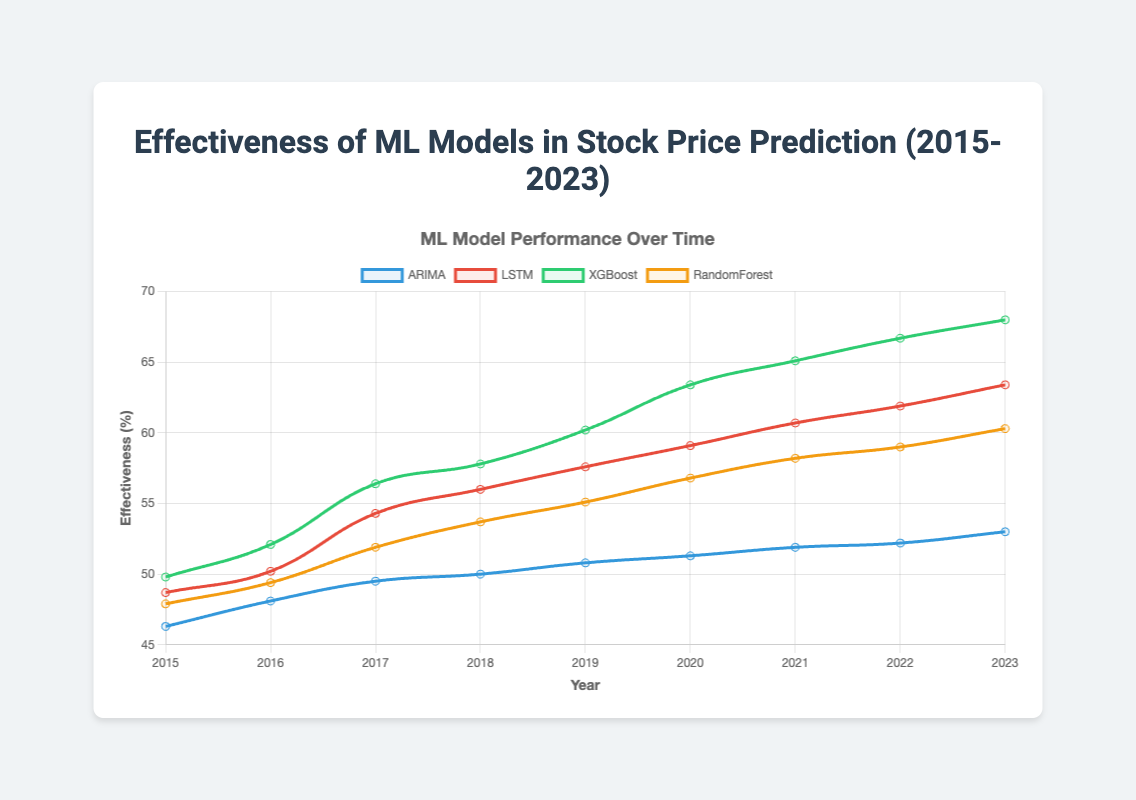what is the effectiveness of LSTM in 2020? Looking at the data, we can see that for the year 2020, the effectiveness of LSTM is listed in the LSTM column. It shows 59.1.
Answer: 59.1 Which model had the highest effectiveness in 2022? By comparing the values of all models in the year 2022, we see that XGBoost has the highest effectiveness value of 66.7.
Answer: XGBoost How many years did ARIMA have an effectiveness value above 50? From the data, ARIMA has effectiveness values above 50 from 2018 to 2023, which makes it 6 years.
Answer: 6 What is the difference in effectiveness between XGBoost and RandomForest in 2019? The effectiveness of XGBoost in 2019 is 60.2, and the effectiveness of RandomForest in 2019 is 55.1. The difference is 60.2 - 55.1 = 5.1.
Answer: 5.1 Between 2015 and 2023, which model shows the largest increase in effectiveness? By subtracting the 2015 effectiveness values from the 2023 values for each model, we get ARIMA: 53.0 - 46.3 = 6.7, LSTM: 63.4 - 48.7 = 14.7, XGBoost: 68.0 - 49.8 = 18.2, RandomForest: 60.3 - 47.9 = 12.4. XGBoost shows the largest increase of 18.2.
Answer: XGBoost What's the average effectiveness of ARIMA between 2015 and 2023? Summing up the yearly effectiveness values of ARIMA from 2015 to 2023, we get: 46.3 + 48.1 + 49.5 + 50.0 + 50.8 + 51.3 + 51.9 + 52.2 + 53.0 = 453.1. Dividing this sum by 9 (the number of years), we get 453.1 / 9 ≈ 50.34.
Answer: 50.34 Which model's effectiveness crosses 60% first, and in which year? Analyzing the data, we can observe that XGBoost first crosses the 60% mark in 2019 with a value of 60.2.
Answer: XGBoost, 2019 What was the difference in effectiveness between LSTM and ARIMA in 2023? In 2023, the effectiveness of LSTM is 63.4 and ARIMA is 53.0. The difference is 63.4 - 53.0 = 10.4.
Answer: 10.4 Which year did RandomForest first achieve an effectiveness value above 55? By checking the values for RandomForest, the first year it achieves an effectiveness value above 55 is 2019 with a value of 55.1.
Answer: 2019 What is the mean effectiveness of XGBoost from 2017 to 2020? The values for XGBoost from 2017 to 2020 are 56.4, 57.8, 60.2, 63.4. Summing these values: 56.4 + 57.8 + 60.2 + 63.4 = 237.8. The mean is 237.8 / 4 = 59.45.
Answer: 59.45 